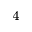<formula> <loc_0><loc_0><loc_500><loc_500>^ { 4 }</formula> 